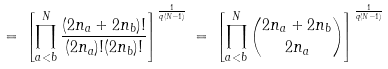Convert formula to latex. <formula><loc_0><loc_0><loc_500><loc_500>= \, \left [ \prod _ { a < b } ^ { N } \frac { ( 2 n _ { a } + 2 n _ { b } ) ! } { ( 2 n _ { a } ) ! ( 2 n _ { b } ) ! } \right ] ^ { \frac { 1 } { q ( N - 1 ) } } \, = \, \left [ \prod _ { a < b } ^ { N } { \binom { 2 n _ { a } + 2 n _ { b } } { 2 n _ { a } } } \right ] ^ { \frac { 1 } { q ( N - 1 ) } }</formula> 